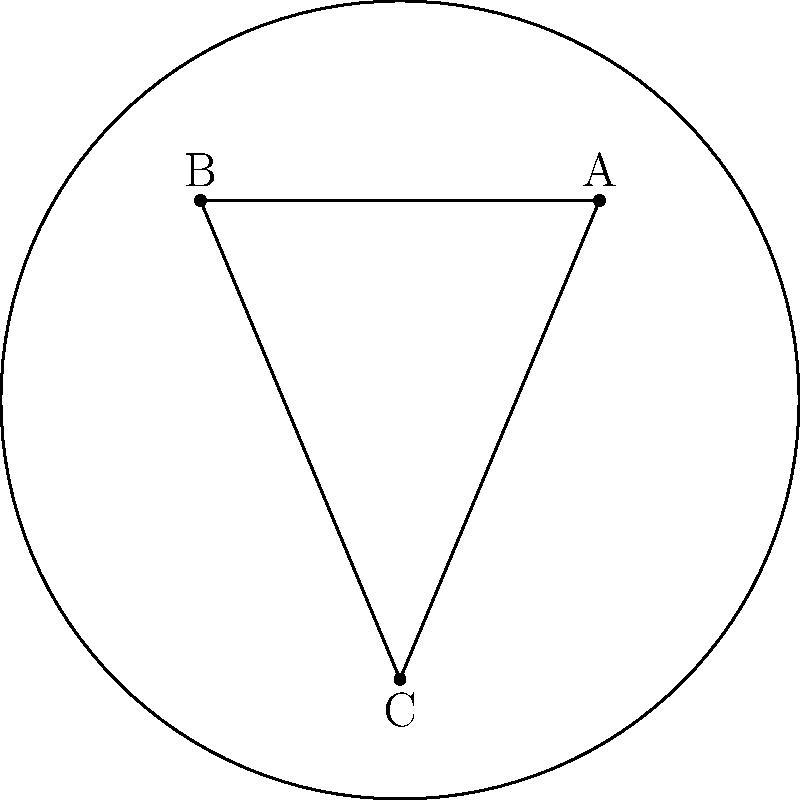In the Poincaré disk model shown above, points A, B, and C form a hyperbolic triangle. If the sum of the interior angles of this triangle is $\frac{5\pi}{6}$, what is the area of the triangle in terms of $\pi$? How might this information be useful in analyzing wind patterns in a specific climate region? To solve this problem, we'll use the Gauss-Bonnet formula for hyperbolic triangles:

1) In Euclidean geometry, the sum of interior angles of a triangle is always $\pi$. In hyperbolic geometry, this sum is always less than $\pi$.

2) The Gauss-Bonnet formula for a hyperbolic triangle states:
   $A = \pi - (\alpha + \beta + \gamma)$
   where $A$ is the area of the triangle, and $\alpha$, $\beta$, and $\gamma$ are the interior angles.

3) We're given that the sum of interior angles is $\frac{5\pi}{6}$. Let's substitute this into our formula:
   $A = \pi - \frac{5\pi}{6}$

4) Simplifying:
   $A = \frac{\pi}{6}$

5) Therefore, the area of the hyperbolic triangle is $\frac{\pi}{6}$.

In terms of wind pattern analysis:
- The Poincaré disk model can represent global wind patterns, with the disk's boundary representing the equator.
- Hyperbolic triangles in this model could represent areas of different air pressure or temperature.
- The area of these triangles could correlate with the intensity of wind systems or the rate of change in weather patterns.
- Understanding these geometric relationships in the Poincaré model could help predict how wind patterns might evolve in response to changing climate conditions, which is crucial for determining optimal growing conditions for new crop varieties.
Answer: $\frac{\pi}{6}$ 